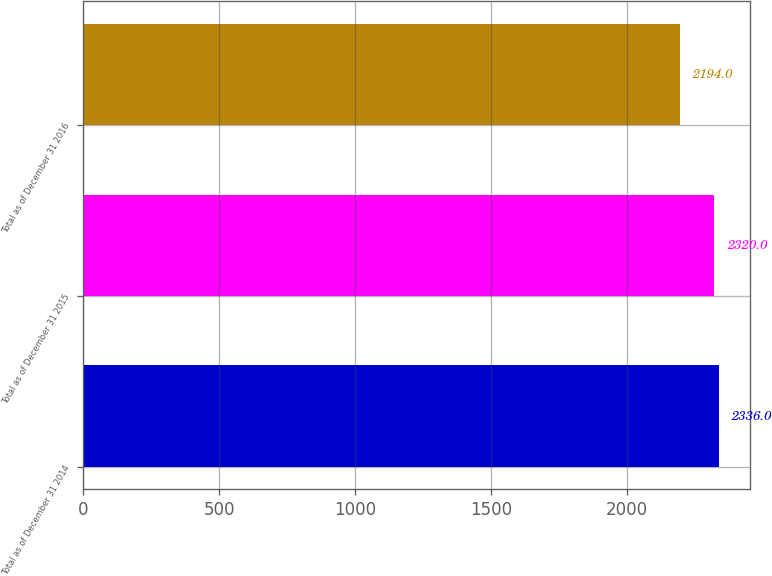Convert chart. <chart><loc_0><loc_0><loc_500><loc_500><bar_chart><fcel>Total as of December 31 2014<fcel>Total as of December 31 2015<fcel>Total as of December 31 2016<nl><fcel>2336<fcel>2320<fcel>2194<nl></chart> 